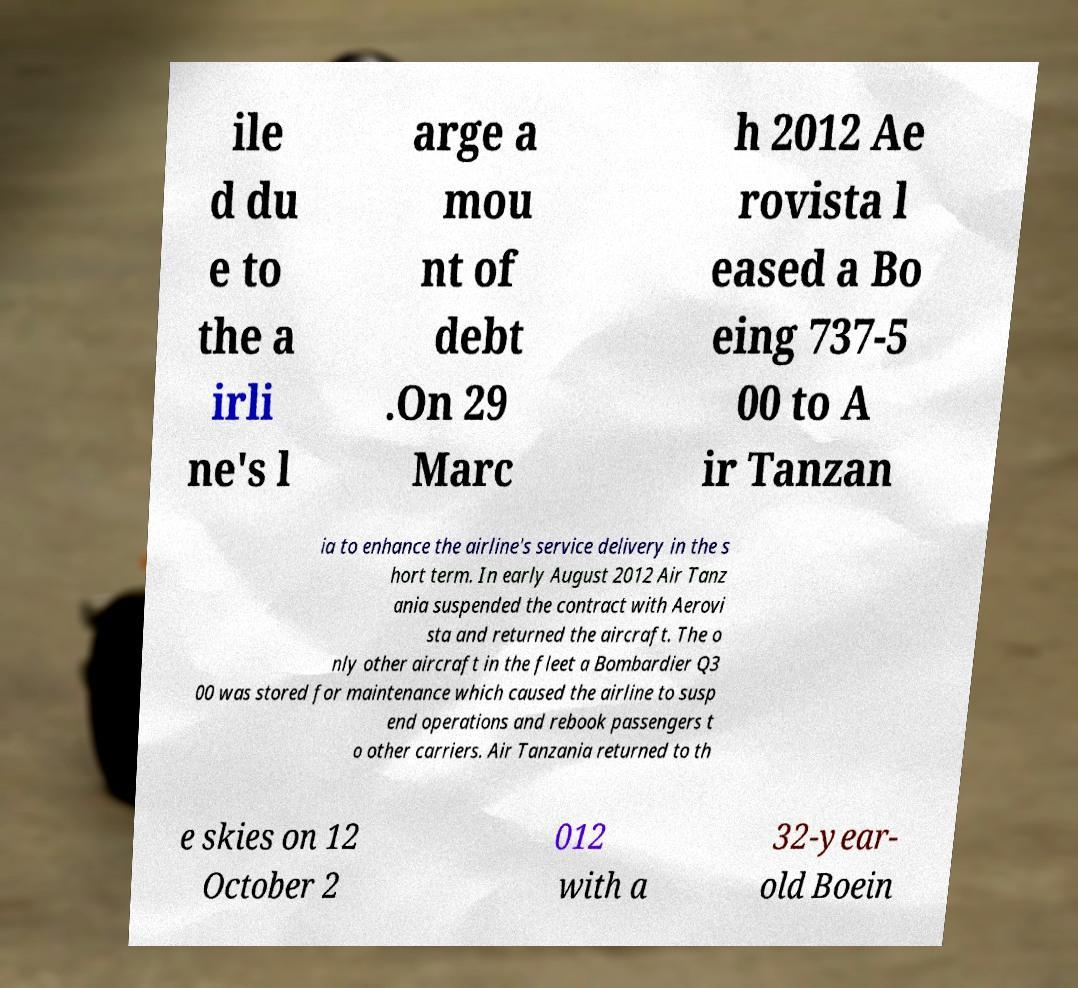Please identify and transcribe the text found in this image. ile d du e to the a irli ne's l arge a mou nt of debt .On 29 Marc h 2012 Ae rovista l eased a Bo eing 737-5 00 to A ir Tanzan ia to enhance the airline's service delivery in the s hort term. In early August 2012 Air Tanz ania suspended the contract with Aerovi sta and returned the aircraft. The o nly other aircraft in the fleet a Bombardier Q3 00 was stored for maintenance which caused the airline to susp end operations and rebook passengers t o other carriers. Air Tanzania returned to th e skies on 12 October 2 012 with a 32-year- old Boein 